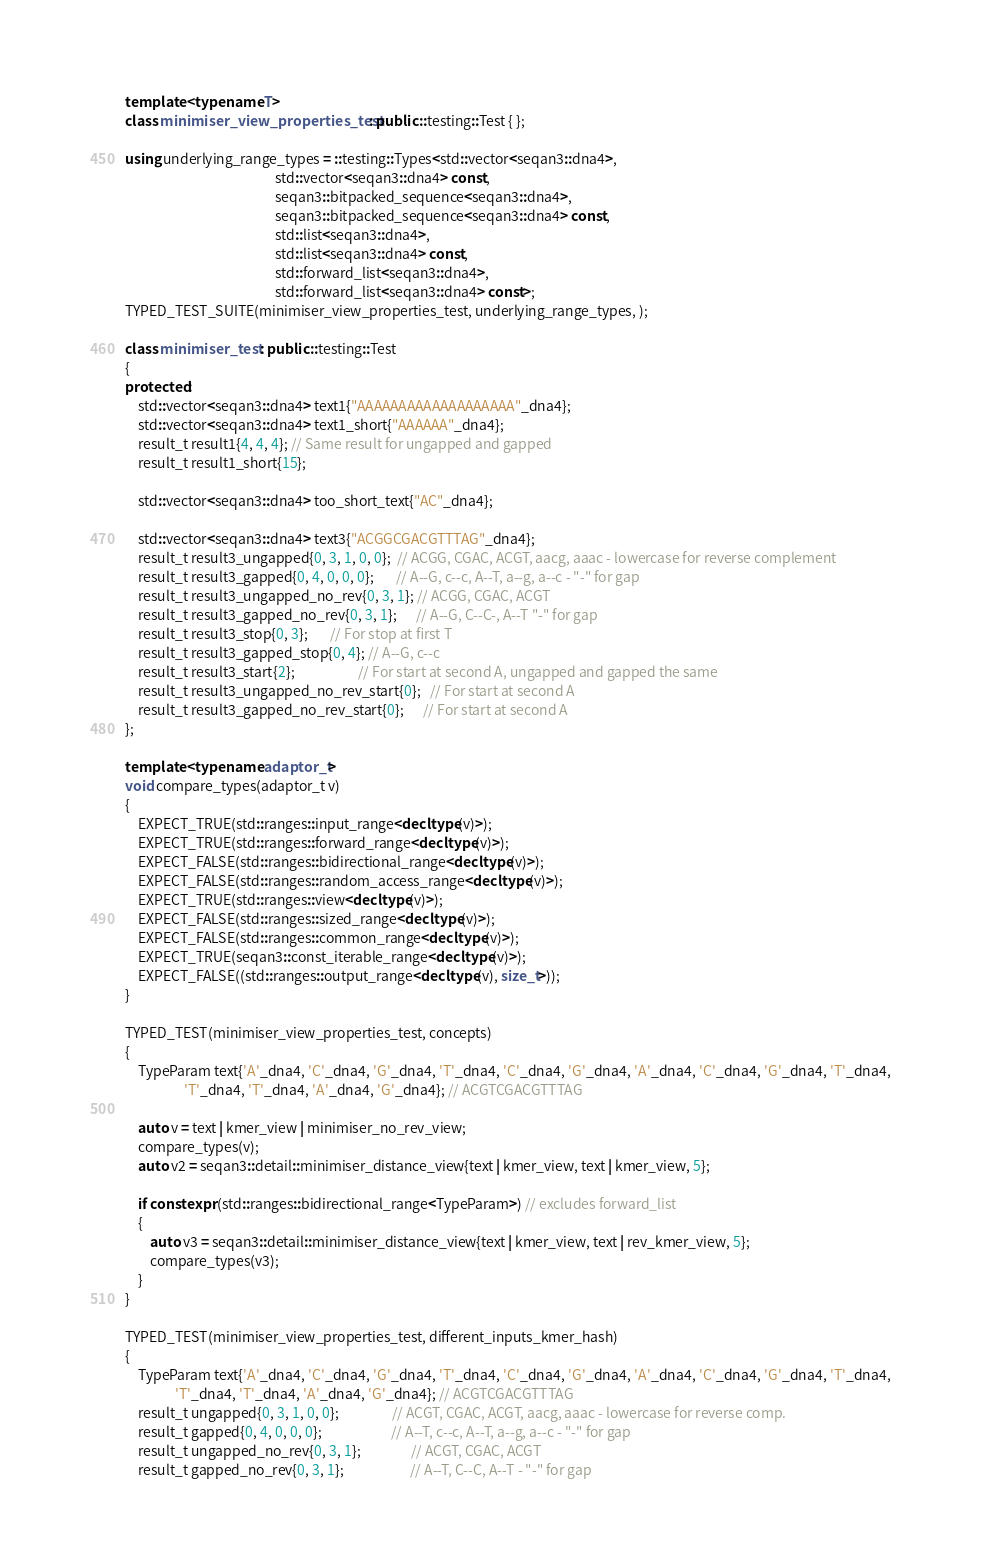<code> <loc_0><loc_0><loc_500><loc_500><_C++_>
template <typename T>
class minimiser_view_properties_test: public ::testing::Test { };

using underlying_range_types = ::testing::Types<std::vector<seqan3::dna4>,
                                                std::vector<seqan3::dna4> const,
                                                seqan3::bitpacked_sequence<seqan3::dna4>,
                                                seqan3::bitpacked_sequence<seqan3::dna4> const,
                                                std::list<seqan3::dna4>,
                                                std::list<seqan3::dna4> const,
                                                std::forward_list<seqan3::dna4>,
                                                std::forward_list<seqan3::dna4> const>;
TYPED_TEST_SUITE(minimiser_view_properties_test, underlying_range_types, );

class minimiser_test : public ::testing::Test
{
protected:
    std::vector<seqan3::dna4> text1{"AAAAAAAAAAAAAAAAAAA"_dna4};
    std::vector<seqan3::dna4> text1_short{"AAAAAA"_dna4};
    result_t result1{4, 4, 4}; // Same result for ungapped and gapped
    result_t result1_short{15};

    std::vector<seqan3::dna4> too_short_text{"AC"_dna4};

    std::vector<seqan3::dna4> text3{"ACGGCGACGTTTAG"_dna4};
    result_t result3_ungapped{0, 3, 1, 0, 0};  // ACGG, CGAC, ACGT, aacg, aaac - lowercase for reverse complement
    result_t result3_gapped{0, 4, 0, 0, 0};       // A--G, c--c, A--T, a--g, a--c - "-" for gap
    result_t result3_ungapped_no_rev{0, 3, 1}; // ACGG, CGAC, ACGT
    result_t result3_gapped_no_rev{0, 3, 1};      // A--G, C--C-, A--T "-" for gap
    result_t result3_stop{0, 3};       // For stop at first T
    result_t result3_gapped_stop{0, 4}; // A--G, c--c
    result_t result3_start{2};                    // For start at second A, ungapped and gapped the same
    result_t result3_ungapped_no_rev_start{0};   // For start at second A
    result_t result3_gapped_no_rev_start{0};      // For start at second A
};

template <typename adaptor_t>
void compare_types(adaptor_t v)
{
    EXPECT_TRUE(std::ranges::input_range<decltype(v)>);
    EXPECT_TRUE(std::ranges::forward_range<decltype(v)>);
    EXPECT_FALSE(std::ranges::bidirectional_range<decltype(v)>);
    EXPECT_FALSE(std::ranges::random_access_range<decltype(v)>);
    EXPECT_TRUE(std::ranges::view<decltype(v)>);
    EXPECT_FALSE(std::ranges::sized_range<decltype(v)>);
    EXPECT_FALSE(std::ranges::common_range<decltype(v)>);
    EXPECT_TRUE(seqan3::const_iterable_range<decltype(v)>);
    EXPECT_FALSE((std::ranges::output_range<decltype(v), size_t>));
}

TYPED_TEST(minimiser_view_properties_test, concepts)
{
    TypeParam text{'A'_dna4, 'C'_dna4, 'G'_dna4, 'T'_dna4, 'C'_dna4, 'G'_dna4, 'A'_dna4, 'C'_dna4, 'G'_dna4, 'T'_dna4,
                   'T'_dna4, 'T'_dna4, 'A'_dna4, 'G'_dna4}; // ACGTCGACGTTTAG

    auto v = text | kmer_view | minimiser_no_rev_view;
    compare_types(v);
    auto v2 = seqan3::detail::minimiser_distance_view{text | kmer_view, text | kmer_view, 5};

    if constexpr (std::ranges::bidirectional_range<TypeParam>) // excludes forward_list
    {
        auto v3 = seqan3::detail::minimiser_distance_view{text | kmer_view, text | rev_kmer_view, 5};
        compare_types(v3);
    }
}

TYPED_TEST(minimiser_view_properties_test, different_inputs_kmer_hash)
{
    TypeParam text{'A'_dna4, 'C'_dna4, 'G'_dna4, 'T'_dna4, 'C'_dna4, 'G'_dna4, 'A'_dna4, 'C'_dna4, 'G'_dna4, 'T'_dna4,
                'T'_dna4, 'T'_dna4, 'A'_dna4, 'G'_dna4}; // ACGTCGACGTTTAG
    result_t ungapped{0, 3, 1, 0, 0};                 // ACGT, CGAC, ACGT, aacg, aaac - lowercase for reverse comp.
    result_t gapped{0, 4, 0, 0, 0};                      // A--T, c--c, A--T, a--g, a--c - "-" for gap
    result_t ungapped_no_rev{0, 3, 1};                // ACGT, CGAC, ACGT
    result_t gapped_no_rev{0, 3, 1};                     // A--T, C--C, A--T - "-" for gap</code> 